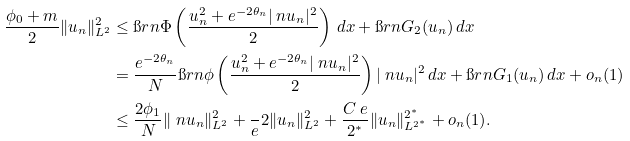<formula> <loc_0><loc_0><loc_500><loc_500>\frac { \phi _ { 0 } + m } { 2 } \| u _ { n } \| _ { L ^ { 2 } } ^ { 2 } & \leq \i r n \Phi \left ( \frac { u _ { n } ^ { 2 } + e ^ { - 2 \theta _ { n } } | \ n u _ { n } | ^ { 2 } } { 2 } \right ) \, d x + \i r n G _ { 2 } ( u _ { n } ) \, d x \\ & = \frac { e ^ { - 2 \theta _ { n } } } N \i r n \phi \left ( \frac { u _ { n } ^ { 2 } + e ^ { - 2 \theta _ { n } } | \ n u _ { n } | ^ { 2 } } { 2 } \right ) | \ n u _ { n } | ^ { 2 } \, d x + \i r n G _ { 1 } ( u _ { n } ) \, d x + o _ { n } ( 1 ) \\ & \leq \frac { 2 \phi _ { 1 } } { N } \| \ n u _ { n } \| ^ { 2 } _ { L ^ { 2 } } + \frac { \ } { e } 2 \| u _ { n } \| ^ { 2 } _ { L ^ { 2 } } + \frac { C _ { \ } e } { 2 ^ { * } } \| u _ { n } \| _ { L ^ { 2 ^ { * } } } ^ { 2 ^ { * } } + o _ { n } ( 1 ) .</formula> 